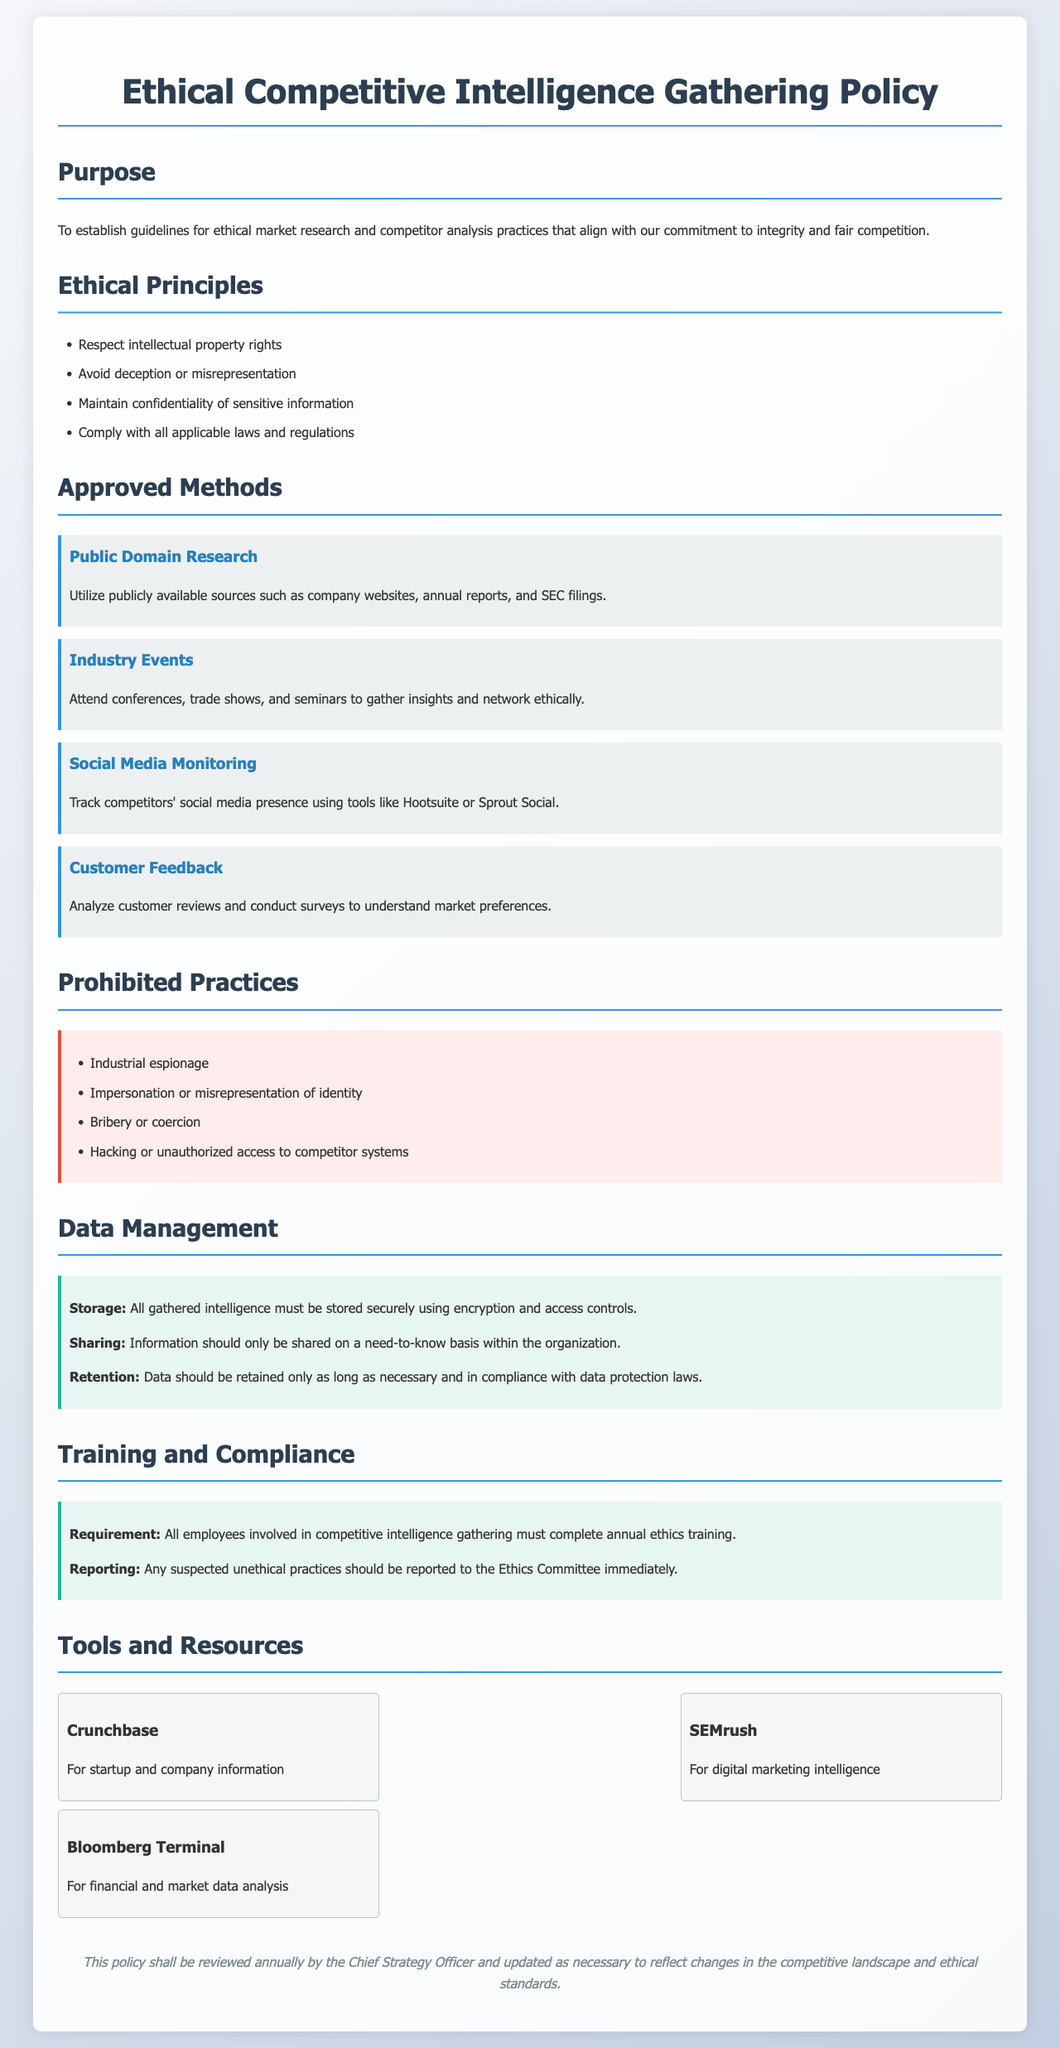What is the purpose of the document? The purpose outlines the guidelines for ethical market research and competitor analysis practices.
Answer: To establish guidelines for ethical market research and competitor analysis practices What is one of the ethical principles? The ethical principles are listed in a bullet format; one of them is respect for intellectual property.
Answer: Respect intellectual property rights Which method involves analyzing customer reviews? The Approved Methods section describes techniques, including one that focuses on customer feedback analysis.
Answer: Customer Feedback What is the tool mentioned for digital marketing intelligence? The Tools and Resources section lists tools; one of them is SEMrush, which focuses on digital marketing.
Answer: SEMrush What should be reported immediately? The Training and Compliance section states actions that should be taken if unethical practices are suspected.
Answer: Any suspected unethical practices How often must employees complete ethics training? The document specifies a requirement for annual ethics training for employees engaged in gathering competitive intelligence.
Answer: Annual What is prohibited regarding competitor systems? The Prohibited Practices section clearly states that certain harmful actions are not allowed, including one involving competitors' systems.
Answer: Hacking or unauthorized access to competitor systems What is required for information sharing? The Data Management section specifies guidelines for sharing information within the organization.
Answer: Need-to-know basis Who is responsible for reviewing the policy? The review process specifies who will conduct the review, noting it is the Chief Strategy Officer.
Answer: Chief Strategy Officer 